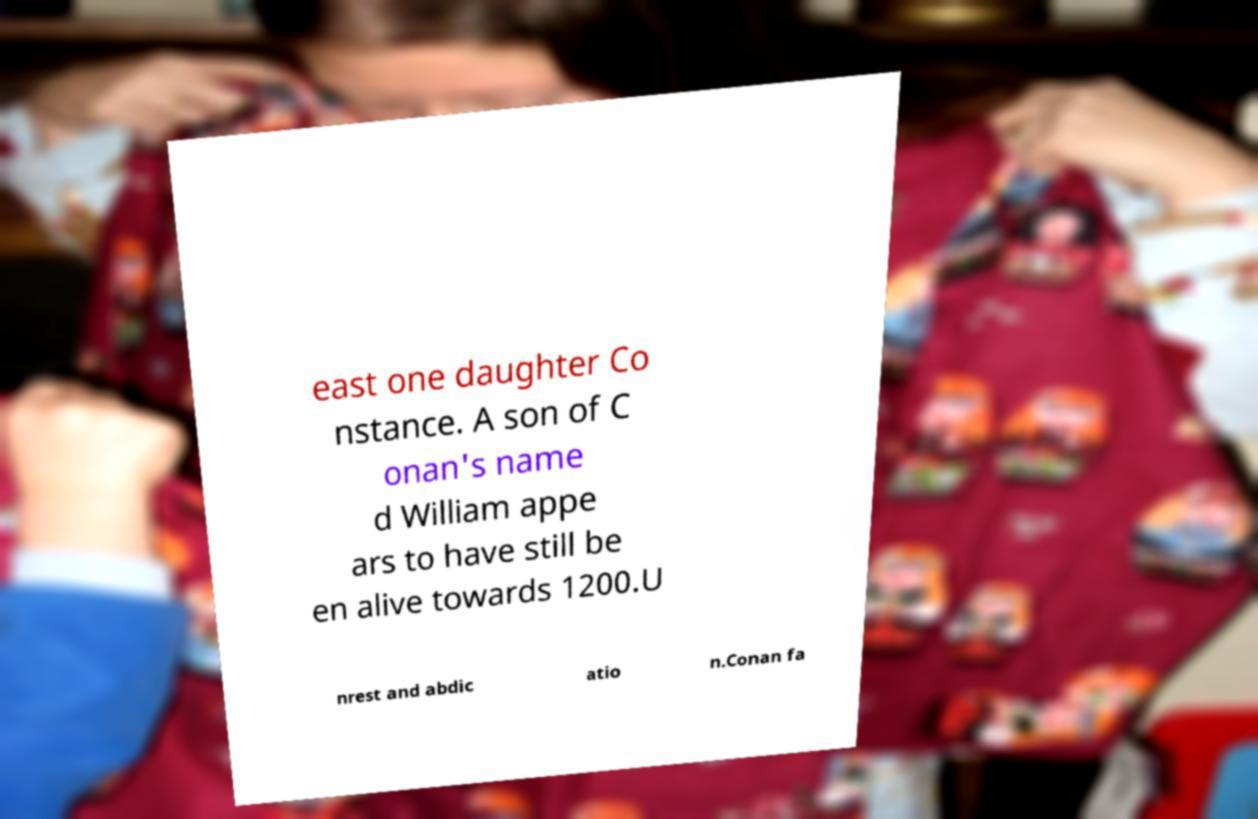Please read and relay the text visible in this image. What does it say? east one daughter Co nstance. A son of C onan's name d William appe ars to have still be en alive towards 1200.U nrest and abdic atio n.Conan fa 